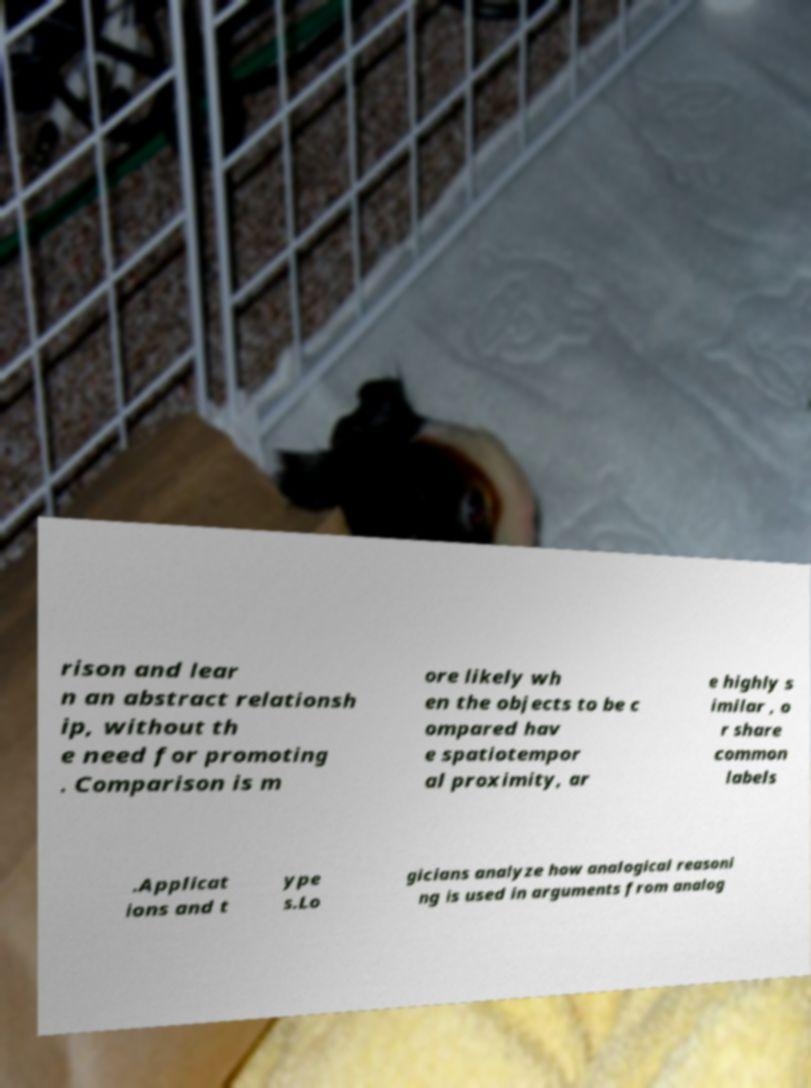Can you accurately transcribe the text from the provided image for me? rison and lear n an abstract relationsh ip, without th e need for promoting . Comparison is m ore likely wh en the objects to be c ompared hav e spatiotempor al proximity, ar e highly s imilar , o r share common labels .Applicat ions and t ype s.Lo gicians analyze how analogical reasoni ng is used in arguments from analog 